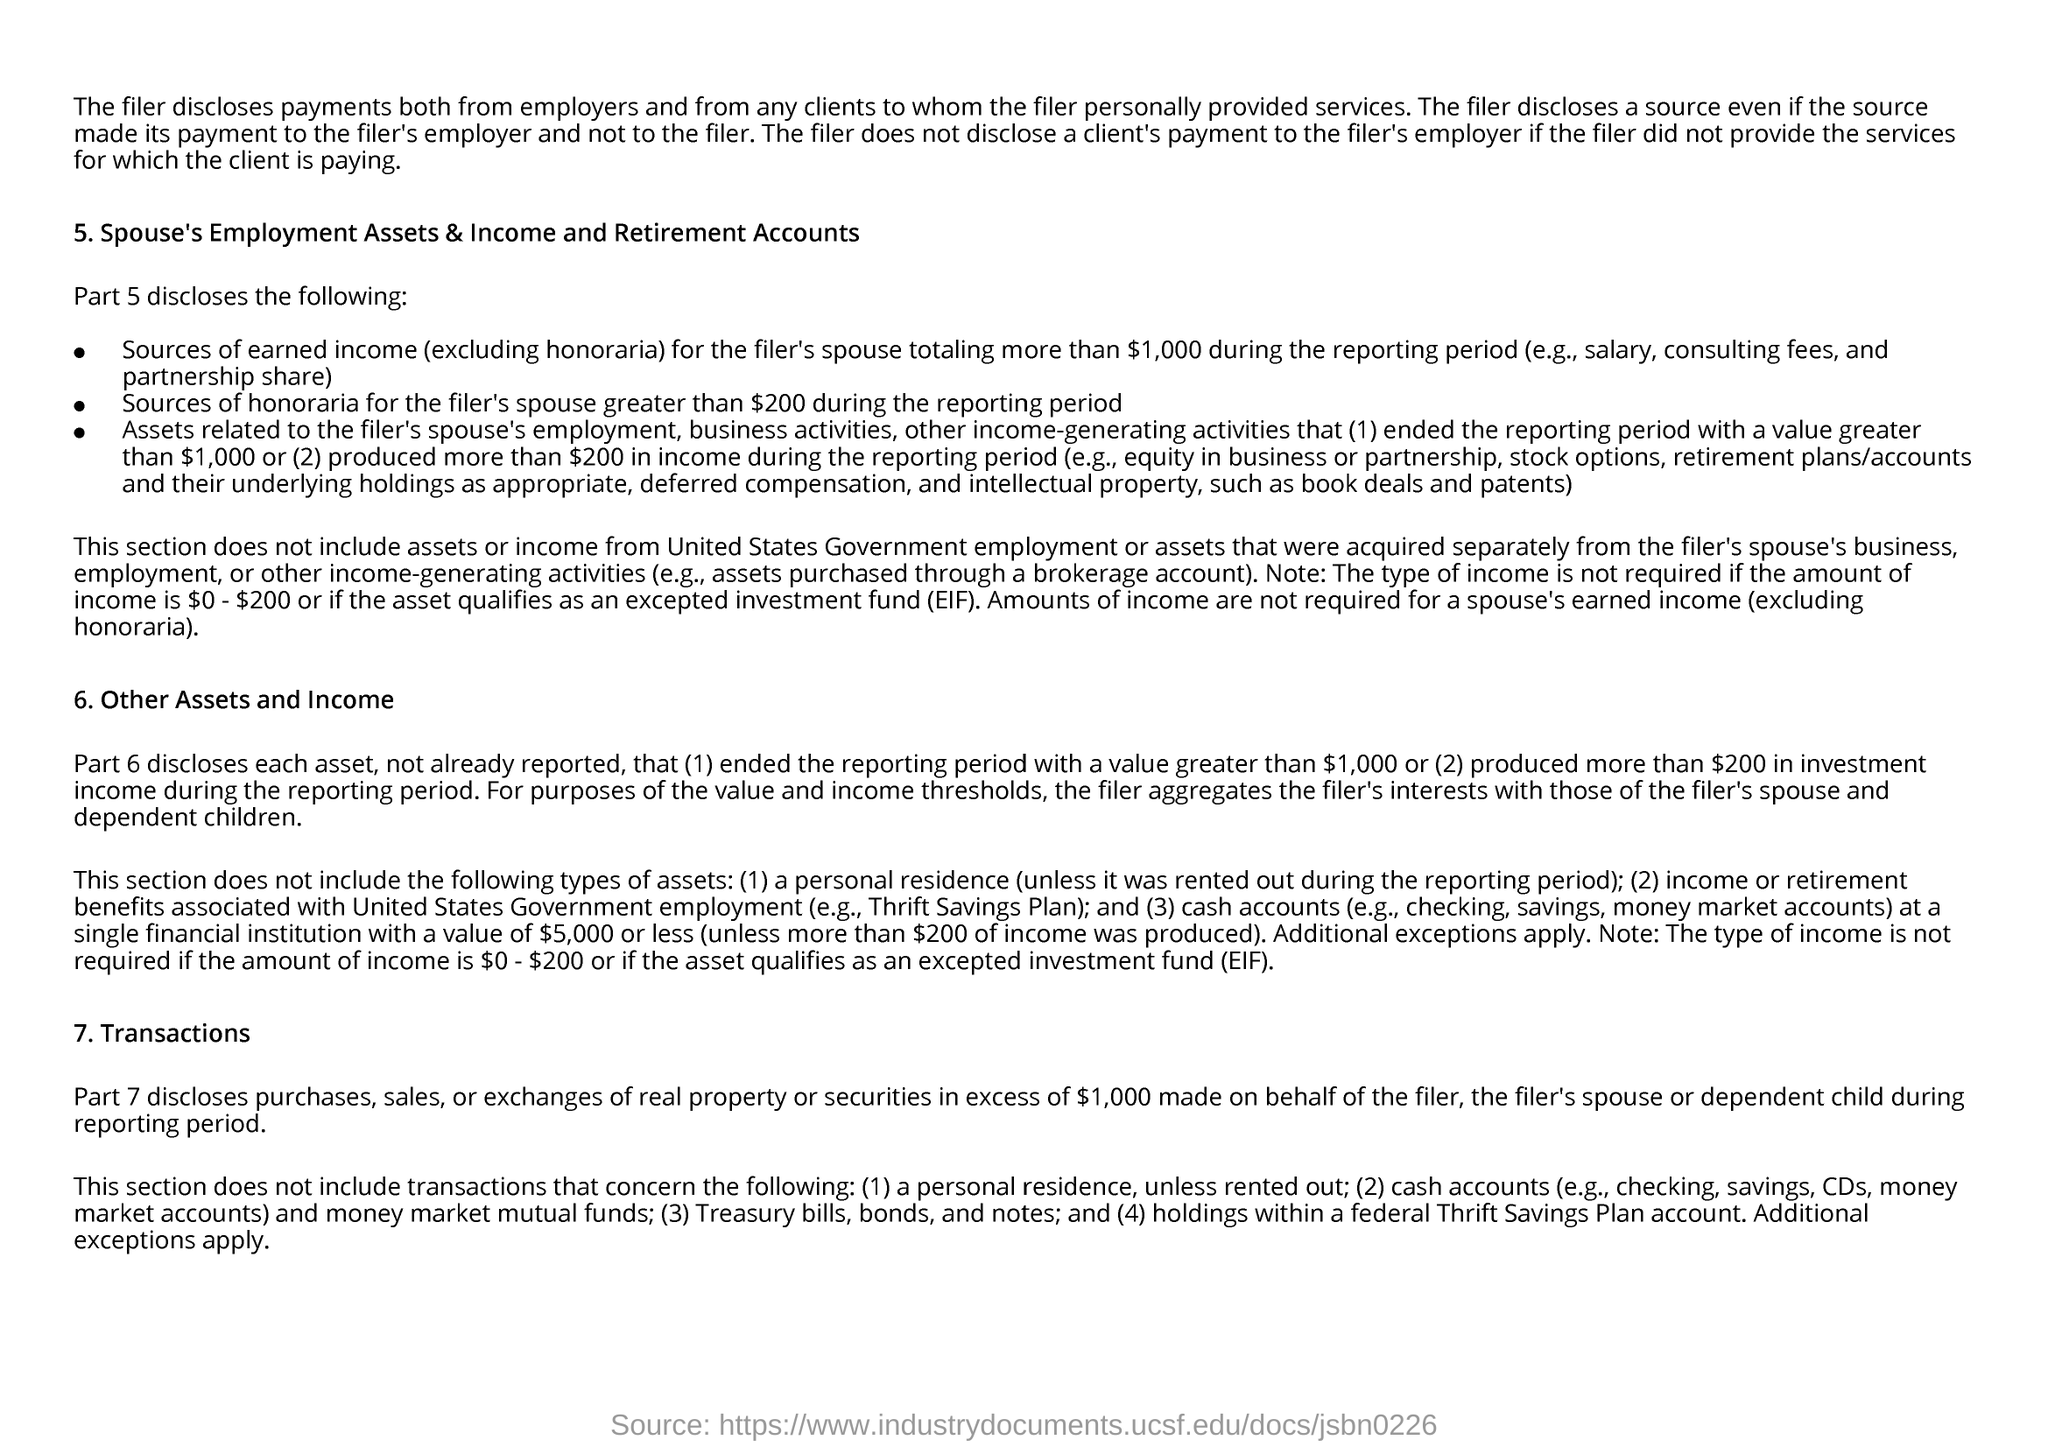From which type of clients the filer discloses payments?
Offer a terse response. From any clients to whom the filer personally provided services. What does EIF stands for?
Keep it short and to the point. Expected Investment Fund. 